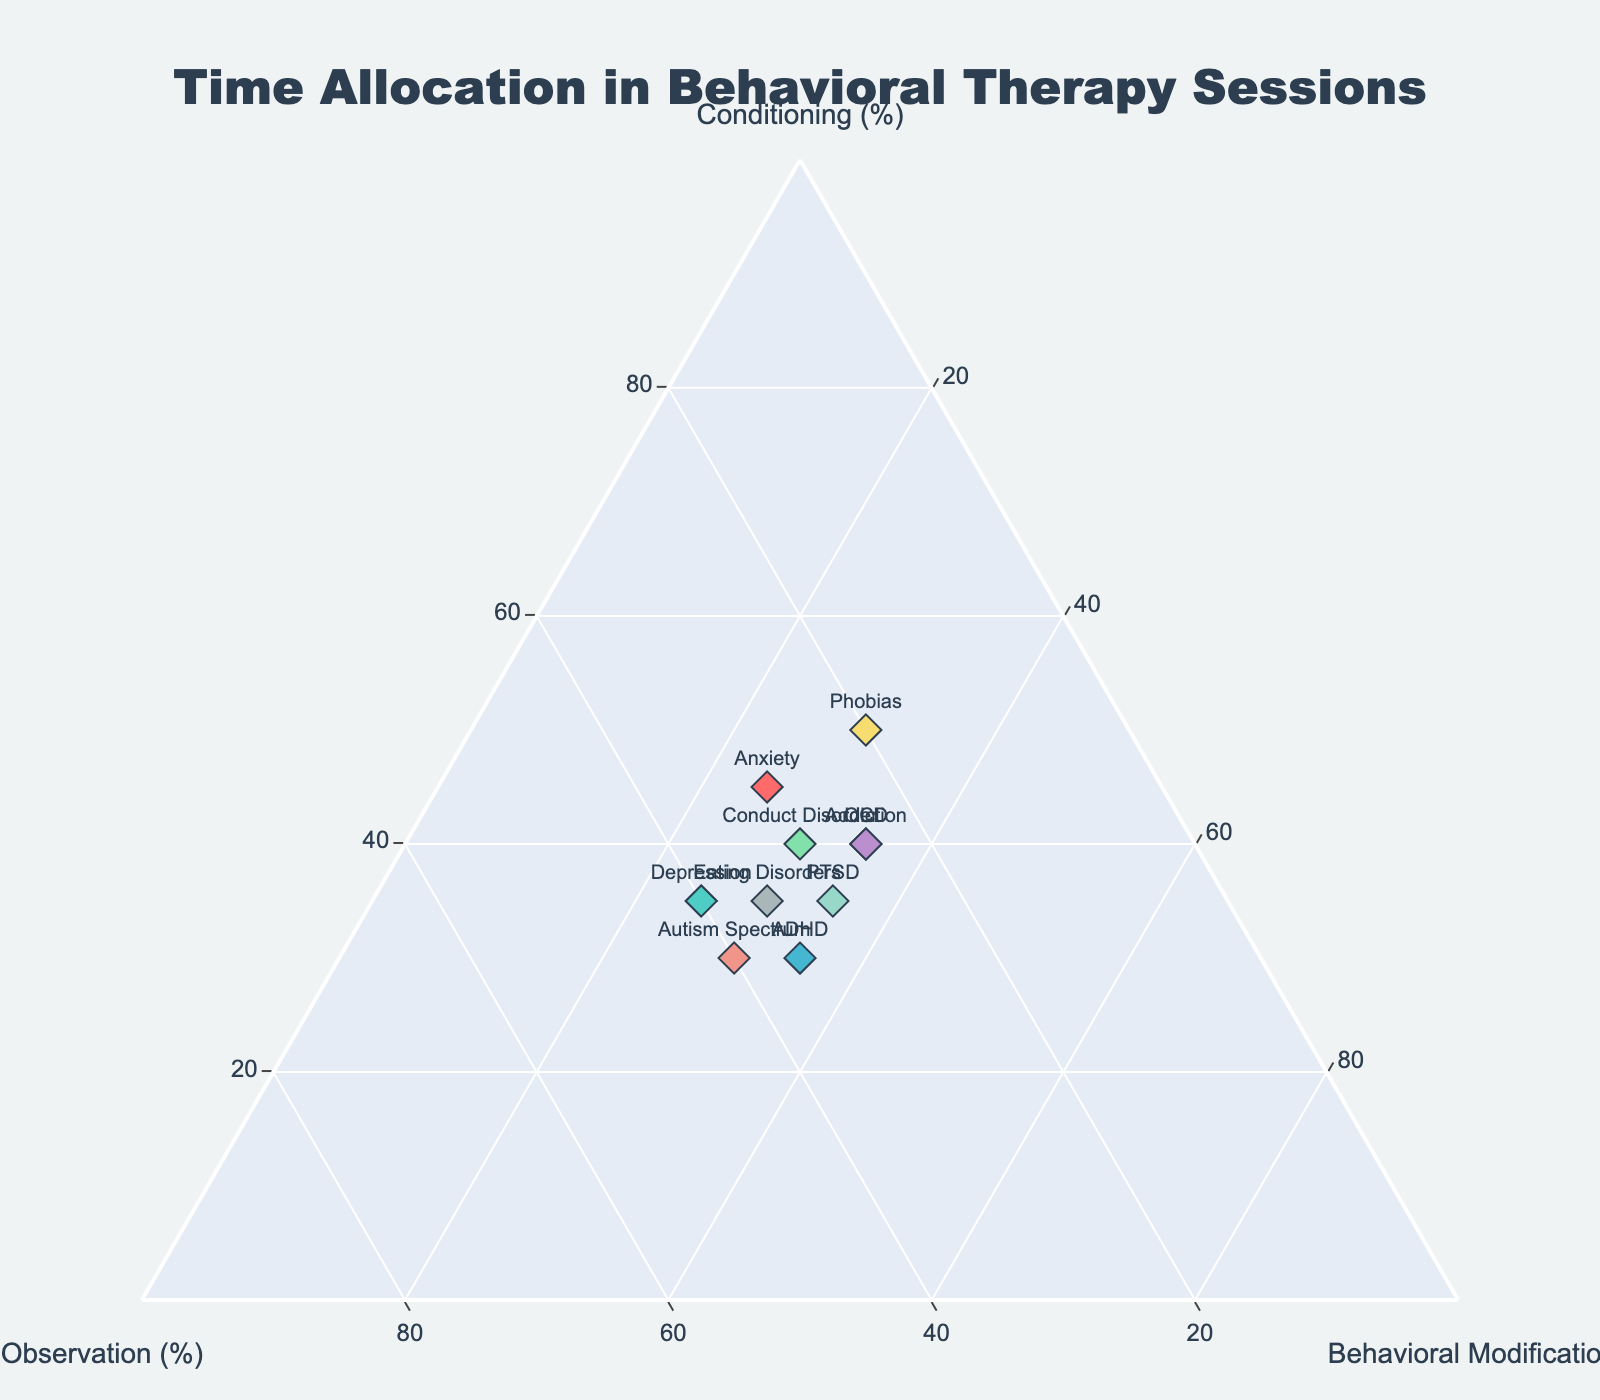How many disorders are represented in the plot? Count the number of unique disorders on the plot.
Answer: 10 Which disorder allocates the highest percentage of time to Conditioning? Look for the point closest to the Conditioning axis (right side of the plot) and read the associated disorder.
Answer: Phobias Which two disorders have the same percentage allocation for Behavioral Modification? Look for points with the same position along the Behavioral Modification axis (bottom axis) and find their labels.
Answer: OCD and Addiction What is the average percentage allocated to Observation across all disorders? Add the percentages for Observation for all disorders and divide by the number of disorders: (30+40+35+25+30+20+25+35+40+30)/10.
Answer: 31 % Which disorder has equal percentages for Observation and Behavioral Modification? Look for the disorder where the Observation and Behavioral Modification values are identical (along the same horizontal axis positions).
Answer: PTSD How does the time allocation for Conditioning compare between Anxiety and Depression? Read the percentages for Conditioning for both disorders and subtract the Depression value from the Anxiety value: 45 - 35.
Answer: Anxiety allocates 10% more Which disorder has the lowest percentage allocated to Conditioning? Locate the point closest to the opposite side of the Conditioning axis (left) and read the associated disorder.
Answer: Autism Spectrum Sum the percentages allocated to Observation and Behavioral Modification for Conduct Disorder. Add the percentages for Observation and Behavioral Modification for Conduct Disorder: 30 + 30.
Answer: 60 % Which disorder shows the most balanced time allocation across all three categories (closest to the center)? Identify the point closest to the center of the ternary plot where all the percentages are roughly equal.
Answer: ADHD What is the difference in Behavioral Modification percentages between Phobias and Eating Disorders? Subtract the percentage of Behavioral Modification for Eating Disorders from that of Phobias: 30 - 30.
Answer: 0 % 